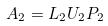<formula> <loc_0><loc_0><loc_500><loc_500>A _ { 2 } = L _ { 2 } U _ { 2 } P _ { 2 }</formula> 